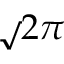Convert formula to latex. <formula><loc_0><loc_0><loc_500><loc_500>\sqrt { 2 } \pi</formula> 